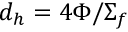<formula> <loc_0><loc_0><loc_500><loc_500>d _ { h } = 4 \Phi / \Sigma _ { f }</formula> 